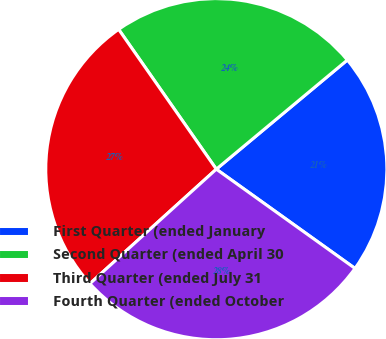Convert chart to OTSL. <chart><loc_0><loc_0><loc_500><loc_500><pie_chart><fcel>First Quarter (ended January<fcel>Second Quarter (ended April 30<fcel>Third Quarter (ended July 31<fcel>Fourth Quarter (ended October<nl><fcel>20.94%<fcel>23.65%<fcel>27.01%<fcel>28.4%<nl></chart> 